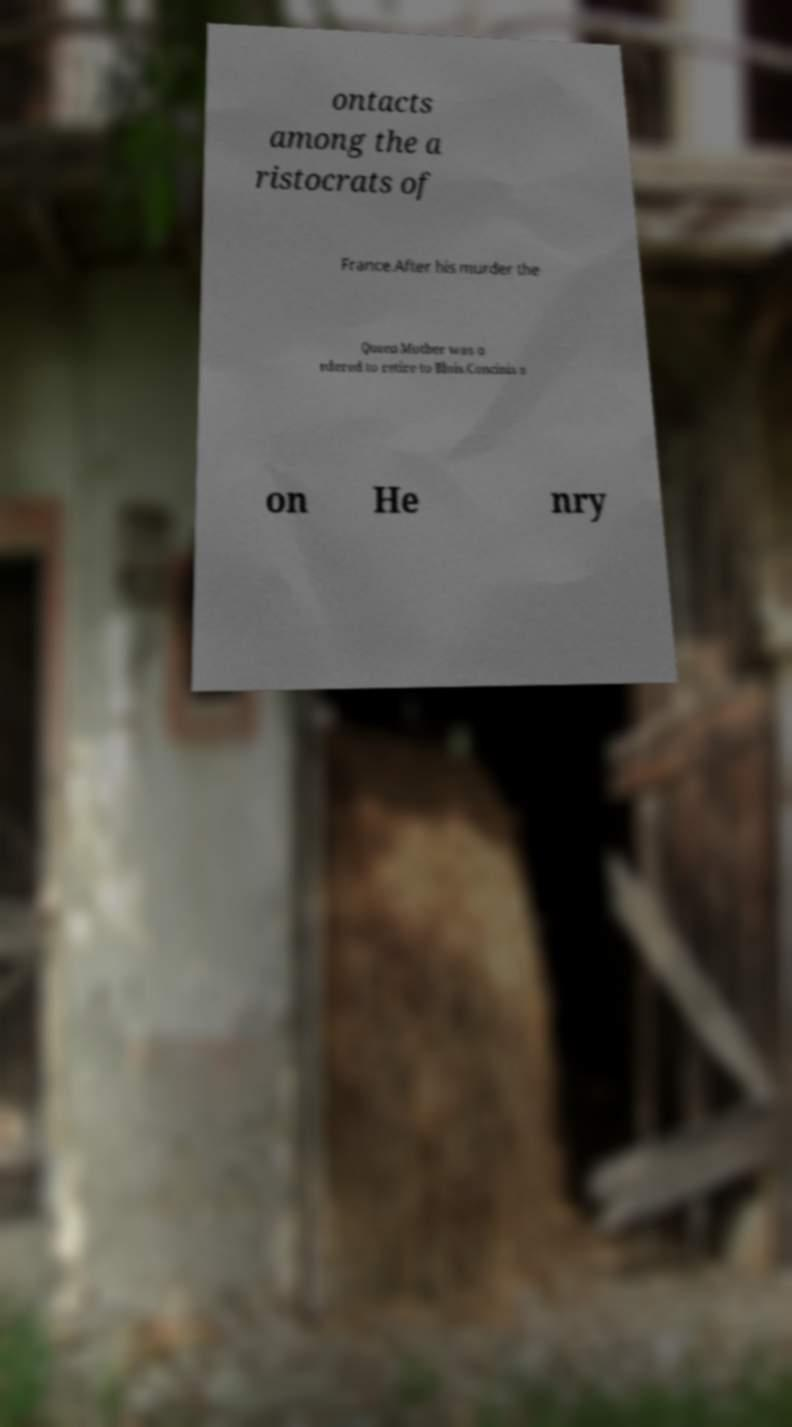What messages or text are displayed in this image? I need them in a readable, typed format. ontacts among the a ristocrats of France.After his murder the Queen Mother was o rdered to retire to Blois.Concinis s on He nry 